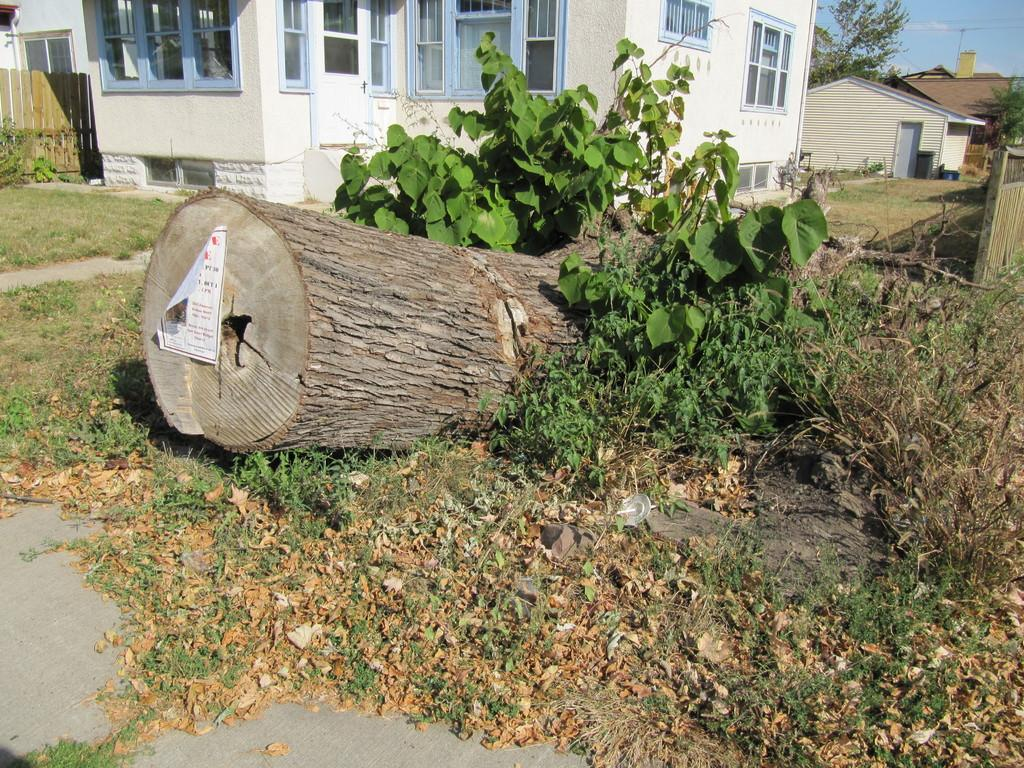What type of living organisms can be seen in the image? Plants and trees are visible in the image. What can be found on the ground in the image? Dry leaves are present in the image. What type of structure is visible in the image? There is a house in the image. What type of barrier is visible in the image? A wooden fence is visible in the image. What type of natural feature is visible in the image? Trees are present in the image. What type of infrastructure is visible in the image? Cables are visible in the image. What part of the natural environment is visible in the image? The sky is visible in the image. What type of appliance is being used to control the temper of the slaves in the image? There is no mention of appliances, slaves, or temper in the image. The image features plants, dry leaves, a house, a wooden fence, trees, cables, and the sky. 